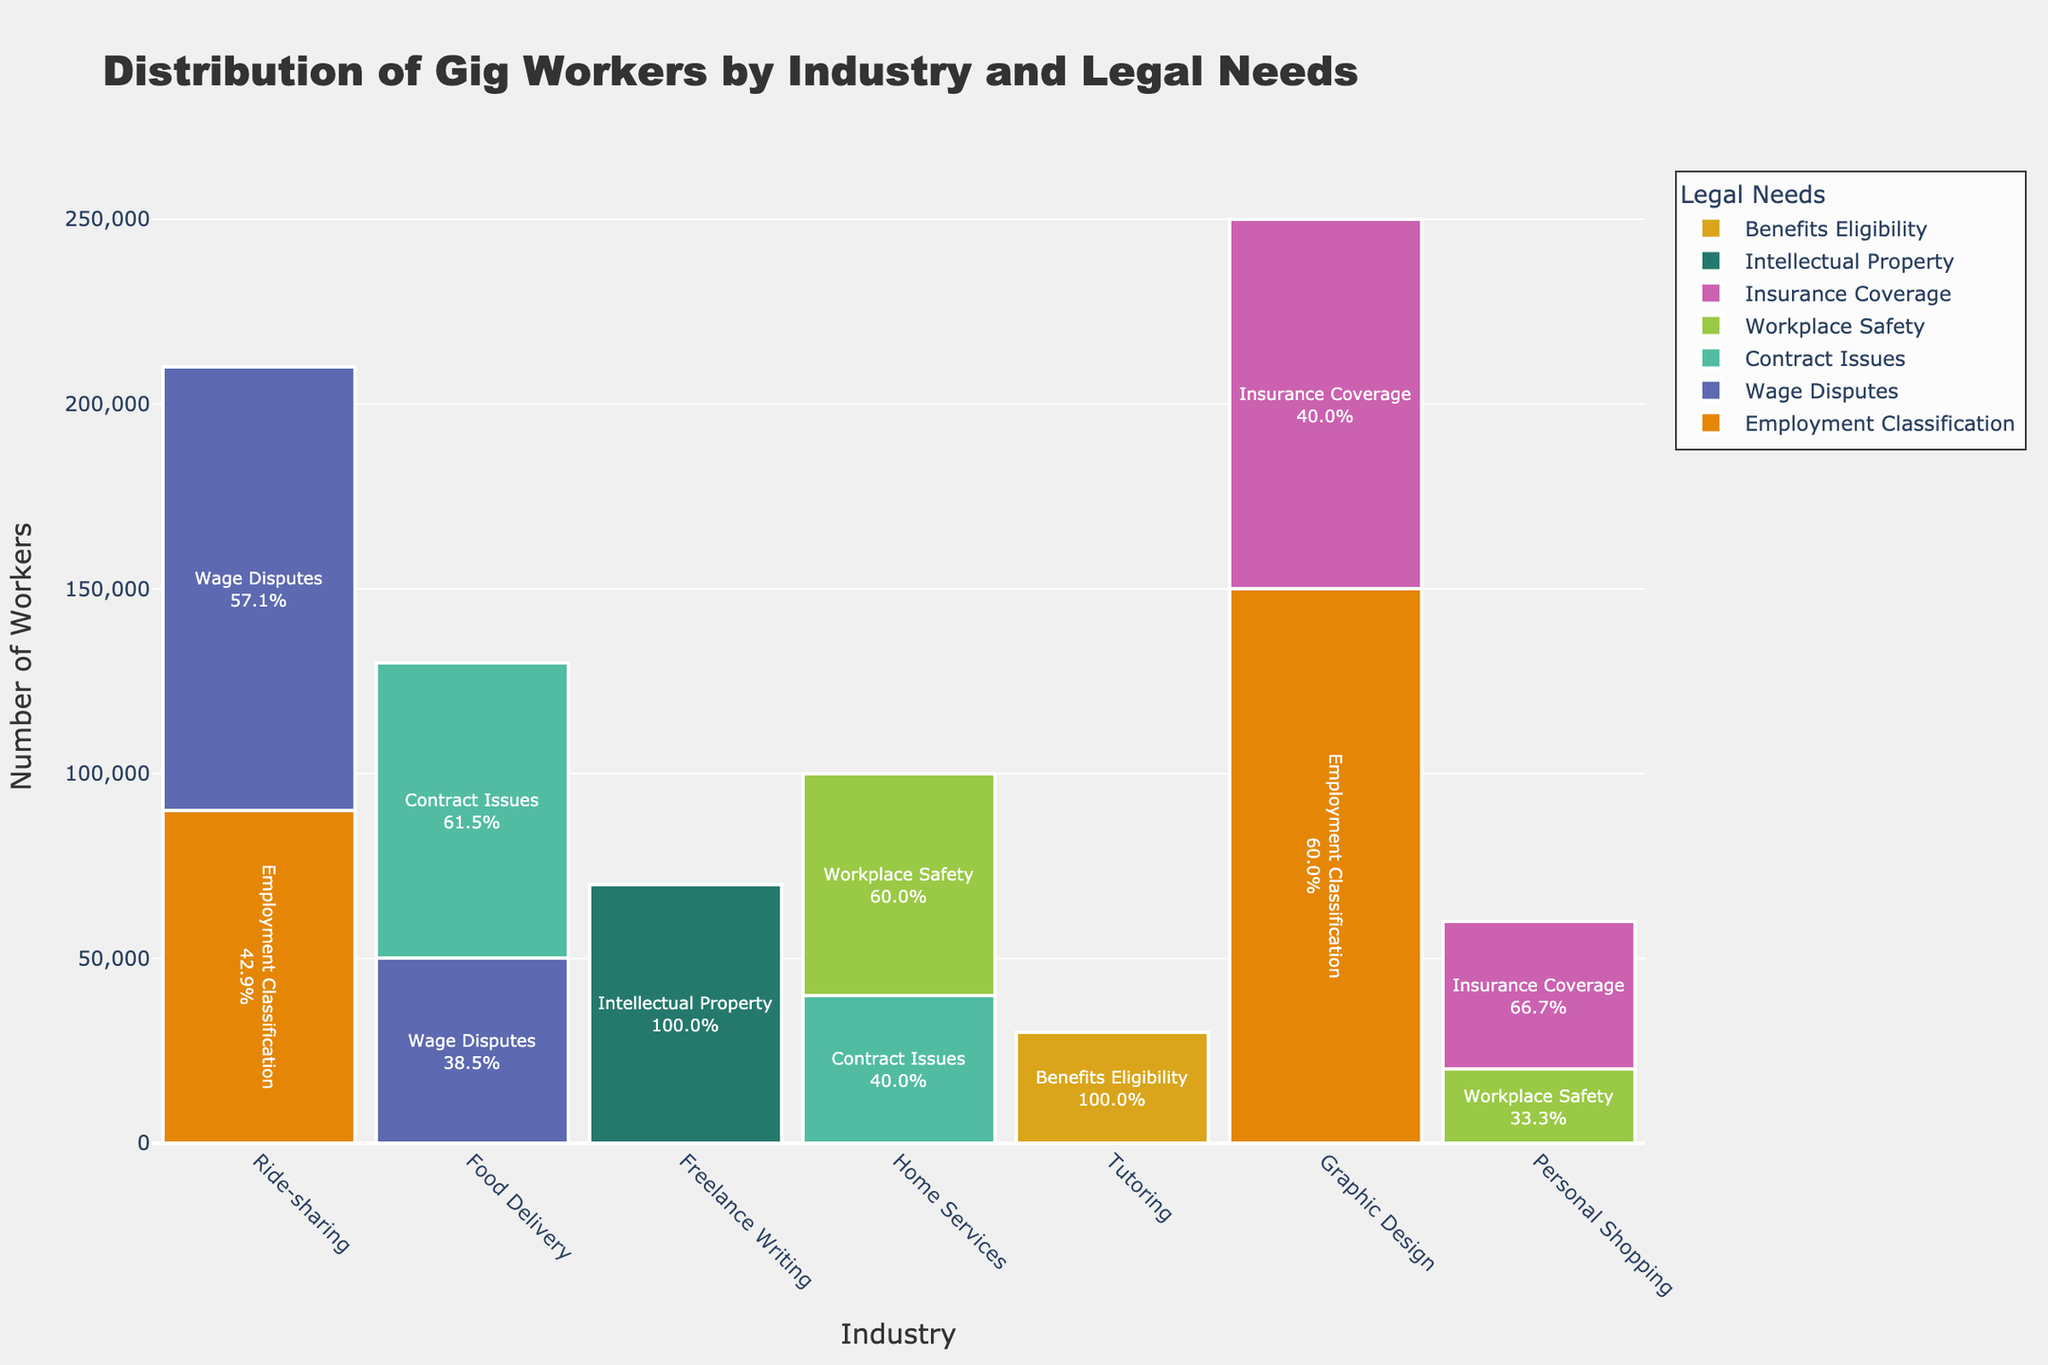what is the title of the Mosaic Plot? The title of the plot is usually displayed at the top of the figure, identified by a larger and bolder font size compared to other text elements. In this case, it reads "Distribution of Gig Workers by Industry and Legal Needs".
Answer: Distribution of Gig Workers by Industry and Legal Needs How many industries are represented in the plot? To count the number of industries, look at the x-axis labels of the figure. Each unique label represents a different industry. Here, the industries listed are Ride-sharing, Food Delivery, Freelance Writing, Home Services, Tutoring, Graphic Design, and Personal Shopping.
Answer: 7 Which industry has the largest number of workers needing "Employment Classification" legal assistance? By looking at the heights of the bars in the "Employment Classification" section, you can compare the industries. The Ride-sharing industry has the tallest bar for "Employment Classification".
Answer: Ride-sharing What is the combined number of workers in the Home Services industry? Sum the heights of all the individual legal need bars for the Home Services industry. The workers in the Home Services industry with various legal needs add up to 60,000 (Workplace Safety) + 40,000 (Contract Issues) = 100,000.
Answer: 100,000 Which legal need is most common among gig workers in the Food Delivery industry? Compare the heights of the different legal needs within the Food Delivery industry. The highest segment in the Food Delivery industry corresponds to "Wage Disputes".
Answer: Wage Disputes How many workers in the Tutoring industry require "Workplace Safety" assistance? By examining the specific section of the Tutoring bar concerned with "Workplace Safety", we can see its height, which corresponds to 20,000 workers.
Answer: 20,000 What proportion of Freelance Writing workers need assistance with "Contract Issues"? Look at the height of the "Contract Issues" bar within the Freelance Writing sector and compare it to the total height of all bars for Freelance Writing workers. "Contract Issues" represents 80,000 out of 130,000, giving us 80,000/130,000 = approximately 61.5%.
Answer: 61.5% Between Ride-sharing and Graphic Design, which industry has more workers requiring "Insurance Coverage"? Compare the heights of the "Insurance Coverage" bars for both industries. Ride-sharing has a higher "Insurance Coverage" bar than Graphic Design with workers.
Answer: Ride-sharing Which legal need is least common across all industries? By adding the heights of each legal need segment across all industries and comparing them, we find that "Intellectual Property" has the least combined height.
Answer: Intellectual Property 